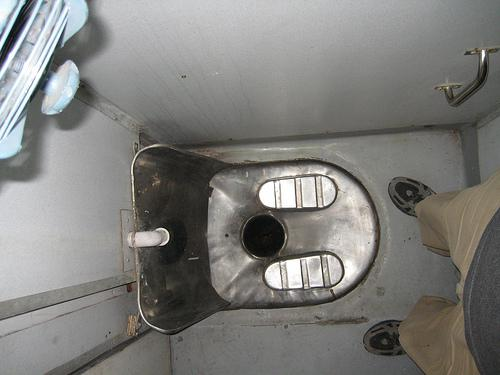Question: where was this picture taken?
Choices:
A. In a kitchen.
B. In a bathroom.
C. In a basement.
D. In an attic.
Answer with the letter. Answer: B Question: what color is the toilet?
Choices:
A. White.
B. Black.
C. Silver.
D. Grey.
Answer with the letter. Answer: C Question: what color are the person's pants?
Choices:
A. White.
B. Black.
C. Khaki.
D. Grey.
Answer with the letter. Answer: C Question: how many legs does the person have?
Choices:
A. 1.
B. 0.
C. 2.
D. 3.
Answer with the letter. Answer: C 